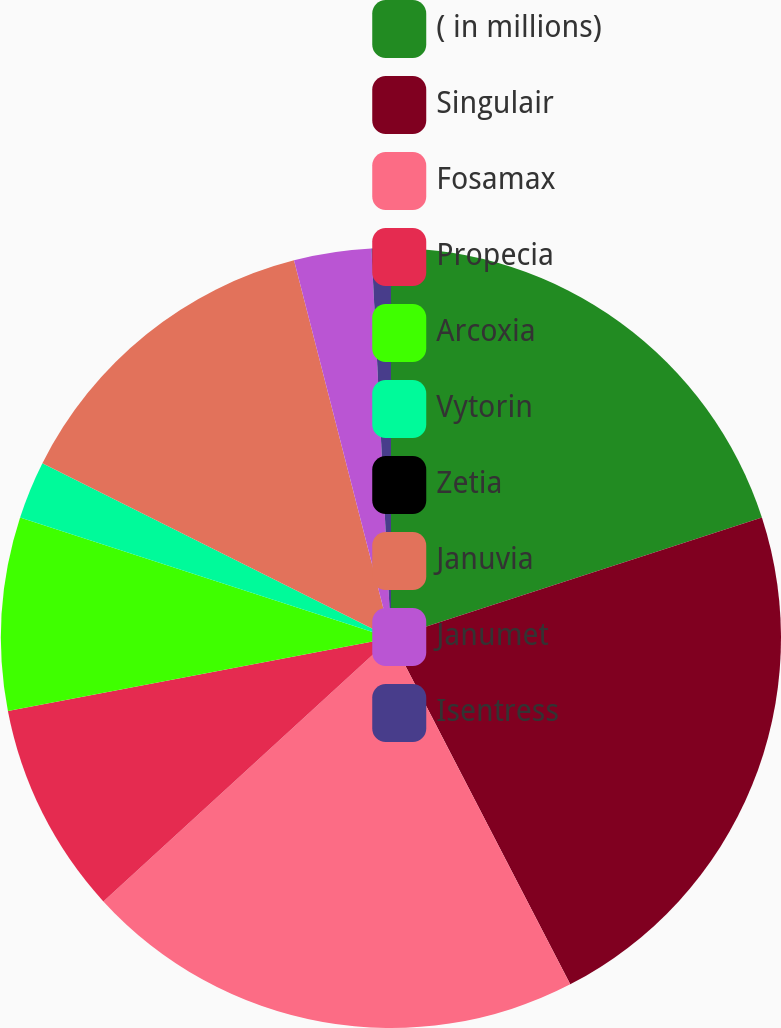<chart> <loc_0><loc_0><loc_500><loc_500><pie_chart><fcel>( in millions)<fcel>Singulair<fcel>Fosamax<fcel>Propecia<fcel>Arcoxia<fcel>Vytorin<fcel>Zetia<fcel>Januvia<fcel>Janumet<fcel>Isentress<nl><fcel>20.0%<fcel>22.4%<fcel>20.8%<fcel>8.8%<fcel>8.0%<fcel>2.4%<fcel>0.0%<fcel>13.6%<fcel>3.2%<fcel>0.8%<nl></chart> 